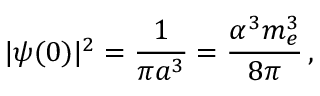<formula> <loc_0><loc_0><loc_500><loc_500>| \psi ( 0 ) | ^ { 2 } = { \frac { 1 } { \pi a ^ { 3 } } } = { \frac { \alpha ^ { 3 } m _ { e } ^ { 3 } } { 8 \pi } } \, ,</formula> 